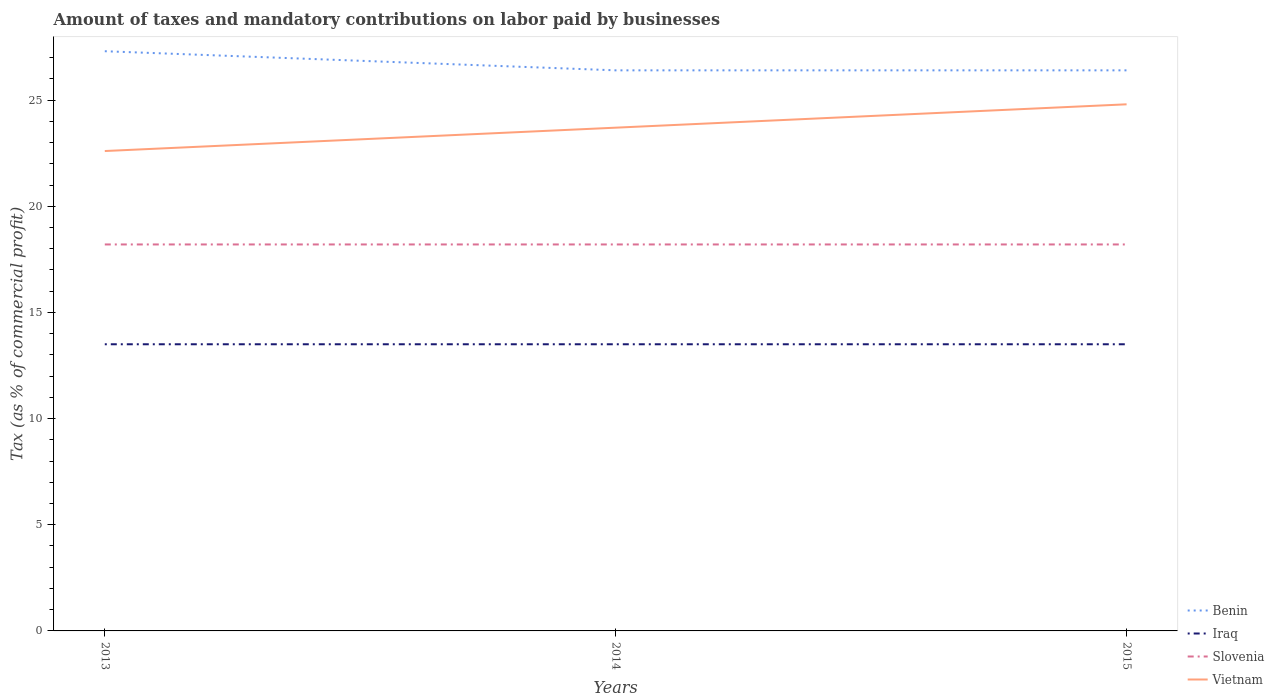Is the number of lines equal to the number of legend labels?
Offer a terse response. Yes. Across all years, what is the maximum percentage of taxes paid by businesses in Iraq?
Provide a succinct answer. 13.5. In which year was the percentage of taxes paid by businesses in Vietnam maximum?
Give a very brief answer. 2013. What is the total percentage of taxes paid by businesses in Iraq in the graph?
Your answer should be very brief. 0. What is the difference between the highest and the second highest percentage of taxes paid by businesses in Slovenia?
Provide a short and direct response. 0. What is the difference between the highest and the lowest percentage of taxes paid by businesses in Iraq?
Your answer should be compact. 0. Does the graph contain any zero values?
Make the answer very short. No. How many legend labels are there?
Provide a succinct answer. 4. What is the title of the graph?
Make the answer very short. Amount of taxes and mandatory contributions on labor paid by businesses. What is the label or title of the Y-axis?
Provide a short and direct response. Tax (as % of commercial profit). What is the Tax (as % of commercial profit) of Benin in 2013?
Your answer should be compact. 27.3. What is the Tax (as % of commercial profit) in Iraq in 2013?
Your answer should be compact. 13.5. What is the Tax (as % of commercial profit) in Slovenia in 2013?
Make the answer very short. 18.2. What is the Tax (as % of commercial profit) in Vietnam in 2013?
Your answer should be very brief. 22.6. What is the Tax (as % of commercial profit) of Benin in 2014?
Keep it short and to the point. 26.4. What is the Tax (as % of commercial profit) of Iraq in 2014?
Provide a succinct answer. 13.5. What is the Tax (as % of commercial profit) in Slovenia in 2014?
Keep it short and to the point. 18.2. What is the Tax (as % of commercial profit) in Vietnam in 2014?
Make the answer very short. 23.7. What is the Tax (as % of commercial profit) in Benin in 2015?
Make the answer very short. 26.4. What is the Tax (as % of commercial profit) of Slovenia in 2015?
Your response must be concise. 18.2. What is the Tax (as % of commercial profit) in Vietnam in 2015?
Offer a very short reply. 24.8. Across all years, what is the maximum Tax (as % of commercial profit) of Benin?
Make the answer very short. 27.3. Across all years, what is the maximum Tax (as % of commercial profit) in Iraq?
Provide a short and direct response. 13.5. Across all years, what is the maximum Tax (as % of commercial profit) of Vietnam?
Keep it short and to the point. 24.8. Across all years, what is the minimum Tax (as % of commercial profit) in Benin?
Your response must be concise. 26.4. Across all years, what is the minimum Tax (as % of commercial profit) of Iraq?
Ensure brevity in your answer.  13.5. Across all years, what is the minimum Tax (as % of commercial profit) of Slovenia?
Your response must be concise. 18.2. Across all years, what is the minimum Tax (as % of commercial profit) of Vietnam?
Offer a very short reply. 22.6. What is the total Tax (as % of commercial profit) in Benin in the graph?
Offer a terse response. 80.1. What is the total Tax (as % of commercial profit) in Iraq in the graph?
Provide a short and direct response. 40.5. What is the total Tax (as % of commercial profit) of Slovenia in the graph?
Give a very brief answer. 54.6. What is the total Tax (as % of commercial profit) in Vietnam in the graph?
Provide a short and direct response. 71.1. What is the difference between the Tax (as % of commercial profit) in Iraq in 2013 and that in 2014?
Offer a terse response. 0. What is the difference between the Tax (as % of commercial profit) of Iraq in 2013 and that in 2015?
Your answer should be compact. 0. What is the difference between the Tax (as % of commercial profit) of Slovenia in 2014 and that in 2015?
Your answer should be compact. 0. What is the difference between the Tax (as % of commercial profit) in Benin in 2013 and the Tax (as % of commercial profit) in Slovenia in 2014?
Your answer should be compact. 9.1. What is the difference between the Tax (as % of commercial profit) of Slovenia in 2013 and the Tax (as % of commercial profit) of Vietnam in 2014?
Give a very brief answer. -5.5. What is the difference between the Tax (as % of commercial profit) of Slovenia in 2013 and the Tax (as % of commercial profit) of Vietnam in 2015?
Provide a short and direct response. -6.6. What is the difference between the Tax (as % of commercial profit) in Benin in 2014 and the Tax (as % of commercial profit) in Slovenia in 2015?
Provide a short and direct response. 8.2. What is the average Tax (as % of commercial profit) in Benin per year?
Your response must be concise. 26.7. What is the average Tax (as % of commercial profit) of Iraq per year?
Ensure brevity in your answer.  13.5. What is the average Tax (as % of commercial profit) in Slovenia per year?
Provide a succinct answer. 18.2. What is the average Tax (as % of commercial profit) in Vietnam per year?
Provide a short and direct response. 23.7. In the year 2013, what is the difference between the Tax (as % of commercial profit) of Benin and Tax (as % of commercial profit) of Iraq?
Provide a succinct answer. 13.8. In the year 2013, what is the difference between the Tax (as % of commercial profit) in Slovenia and Tax (as % of commercial profit) in Vietnam?
Ensure brevity in your answer.  -4.4. In the year 2014, what is the difference between the Tax (as % of commercial profit) of Benin and Tax (as % of commercial profit) of Iraq?
Your response must be concise. 12.9. In the year 2014, what is the difference between the Tax (as % of commercial profit) in Benin and Tax (as % of commercial profit) in Vietnam?
Keep it short and to the point. 2.7. In the year 2014, what is the difference between the Tax (as % of commercial profit) in Slovenia and Tax (as % of commercial profit) in Vietnam?
Offer a very short reply. -5.5. In the year 2015, what is the difference between the Tax (as % of commercial profit) in Iraq and Tax (as % of commercial profit) in Vietnam?
Provide a short and direct response. -11.3. What is the ratio of the Tax (as % of commercial profit) of Benin in 2013 to that in 2014?
Ensure brevity in your answer.  1.03. What is the ratio of the Tax (as % of commercial profit) of Slovenia in 2013 to that in 2014?
Your answer should be very brief. 1. What is the ratio of the Tax (as % of commercial profit) of Vietnam in 2013 to that in 2014?
Give a very brief answer. 0.95. What is the ratio of the Tax (as % of commercial profit) of Benin in 2013 to that in 2015?
Ensure brevity in your answer.  1.03. What is the ratio of the Tax (as % of commercial profit) of Iraq in 2013 to that in 2015?
Your answer should be very brief. 1. What is the ratio of the Tax (as % of commercial profit) of Slovenia in 2013 to that in 2015?
Your answer should be compact. 1. What is the ratio of the Tax (as % of commercial profit) in Vietnam in 2013 to that in 2015?
Make the answer very short. 0.91. What is the ratio of the Tax (as % of commercial profit) in Benin in 2014 to that in 2015?
Provide a short and direct response. 1. What is the ratio of the Tax (as % of commercial profit) of Slovenia in 2014 to that in 2015?
Your response must be concise. 1. What is the ratio of the Tax (as % of commercial profit) in Vietnam in 2014 to that in 2015?
Make the answer very short. 0.96. What is the difference between the highest and the second highest Tax (as % of commercial profit) in Benin?
Your answer should be compact. 0.9. What is the difference between the highest and the second highest Tax (as % of commercial profit) of Iraq?
Your answer should be very brief. 0. What is the difference between the highest and the lowest Tax (as % of commercial profit) of Benin?
Your answer should be compact. 0.9. 